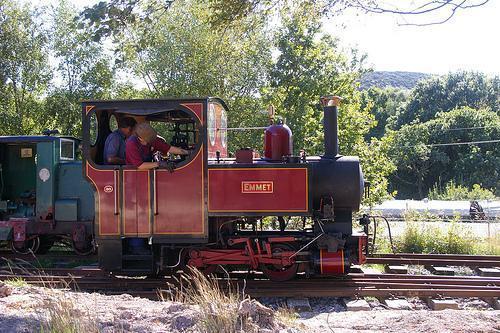How many people in the train?
Give a very brief answer. 2. 